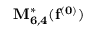Convert formula to latex. <formula><loc_0><loc_0><loc_500><loc_500>M _ { 6 , 4 } ^ { * } ( f ^ { ( 0 ) } )</formula> 